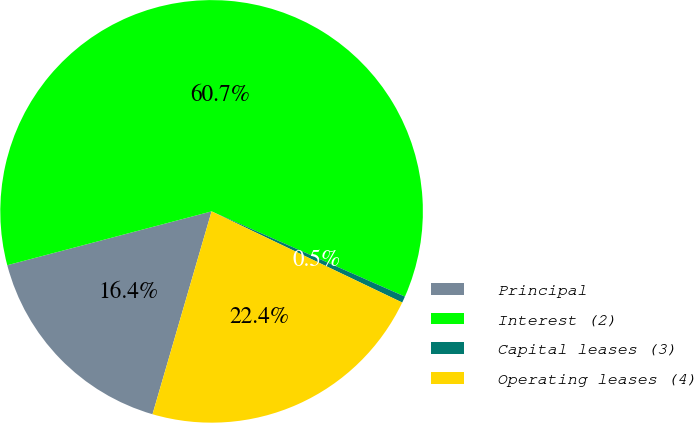Convert chart. <chart><loc_0><loc_0><loc_500><loc_500><pie_chart><fcel>Principal<fcel>Interest (2)<fcel>Capital leases (3)<fcel>Operating leases (4)<nl><fcel>16.39%<fcel>60.71%<fcel>0.49%<fcel>22.41%<nl></chart> 